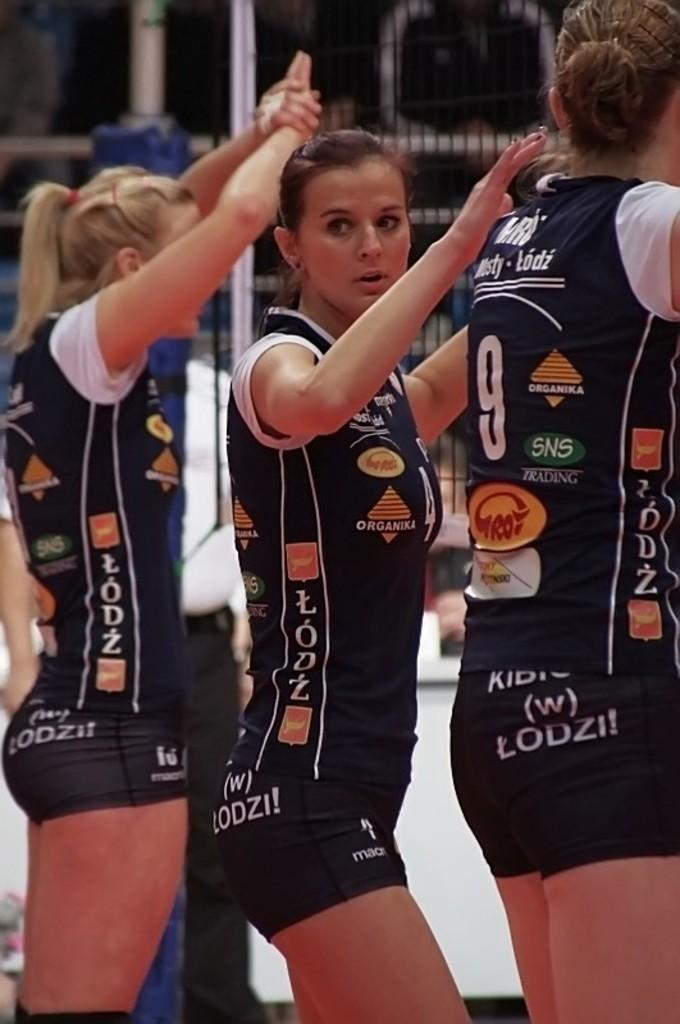Provide a one-sentence caption for the provided image. Three women wearing a uniform with various sponsors like SNS trading. 